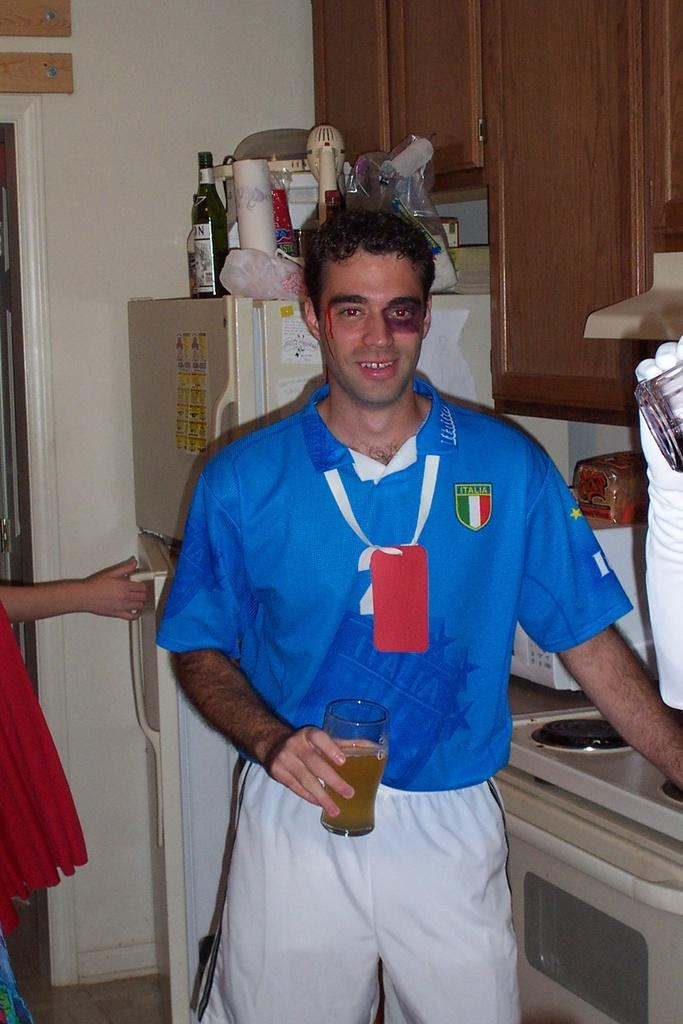<image>
Provide a brief description of the given image. A man with a fake black eye and a blue shirt with an Italia patch holds a glass of beer. 